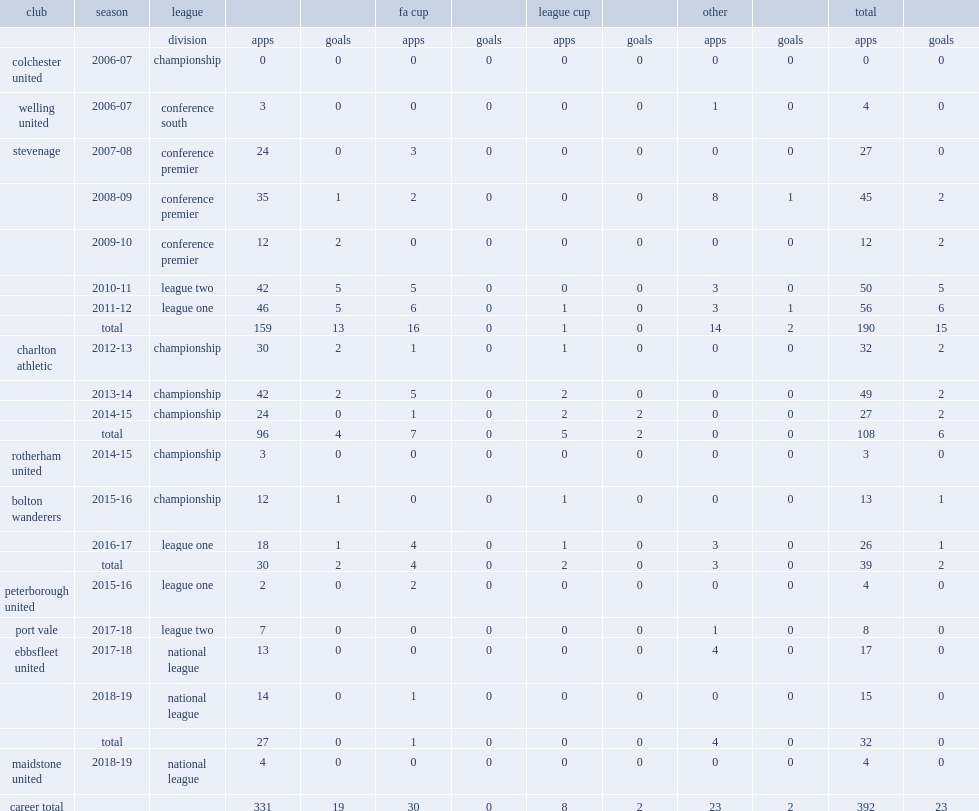Which club did wilson play for in 2011-12? Stevenage. 